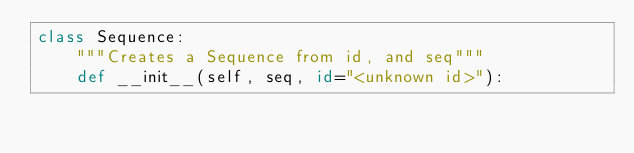Convert code to text. <code><loc_0><loc_0><loc_500><loc_500><_Python_>class Sequence:
    """Creates a Sequence from id, and seq"""
    def __init__(self, seq, id="<unknown id>"):</code> 